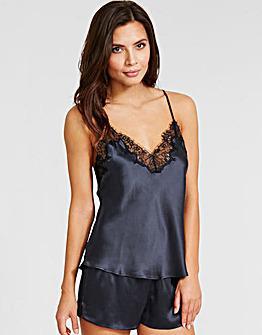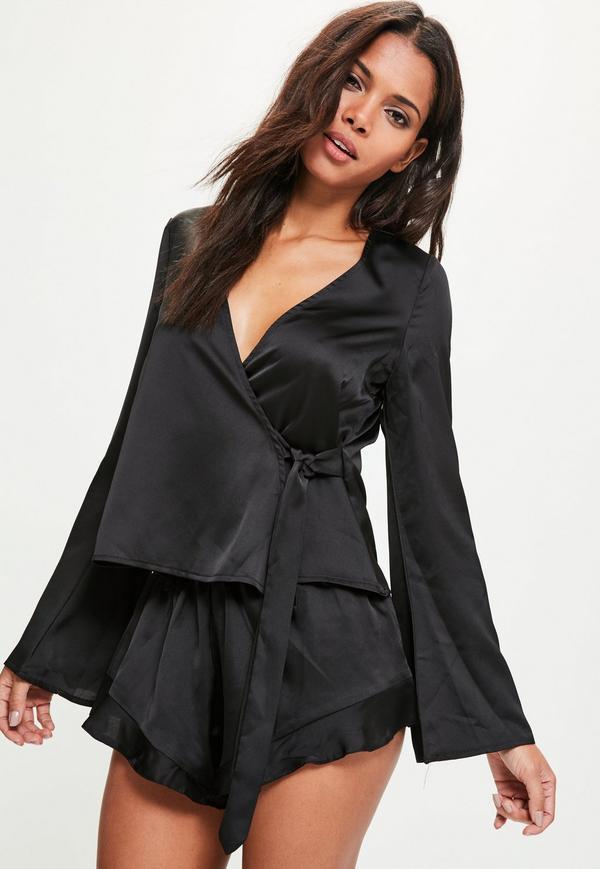The first image is the image on the left, the second image is the image on the right. Given the left and right images, does the statement "the pajamas have white piping accents around the pocket and shorts" hold true? Answer yes or no. No. 